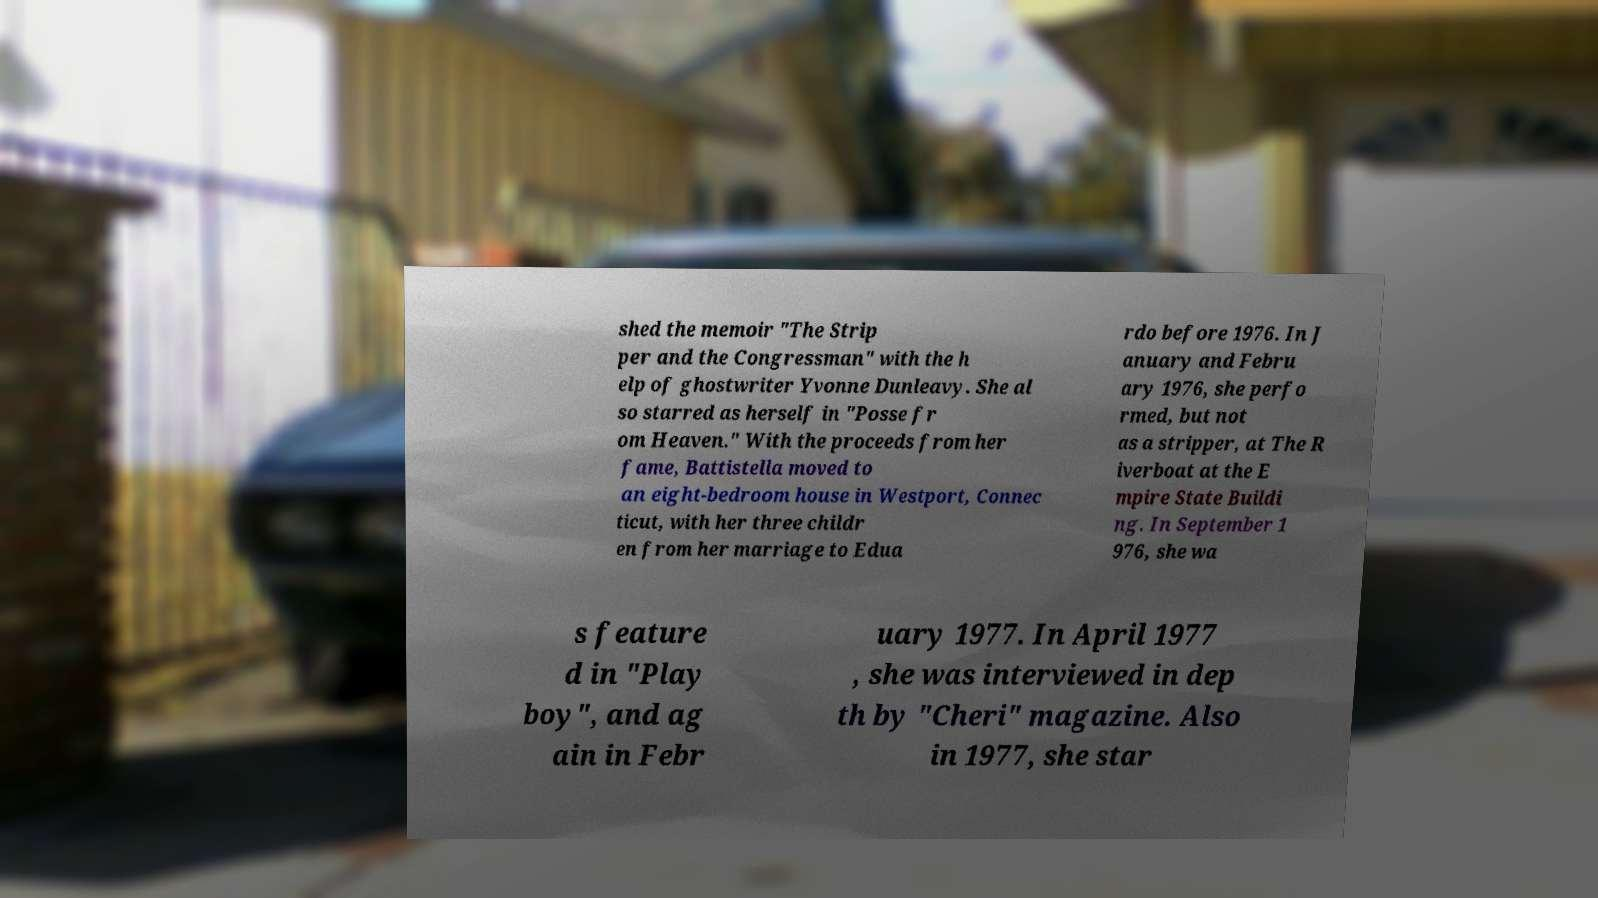There's text embedded in this image that I need extracted. Can you transcribe it verbatim? shed the memoir "The Strip per and the Congressman" with the h elp of ghostwriter Yvonne Dunleavy. She al so starred as herself in "Posse fr om Heaven." With the proceeds from her fame, Battistella moved to an eight-bedroom house in Westport, Connec ticut, with her three childr en from her marriage to Edua rdo before 1976. In J anuary and Febru ary 1976, she perfo rmed, but not as a stripper, at The R iverboat at the E mpire State Buildi ng. In September 1 976, she wa s feature d in "Play boy", and ag ain in Febr uary 1977. In April 1977 , she was interviewed in dep th by "Cheri" magazine. Also in 1977, she star 